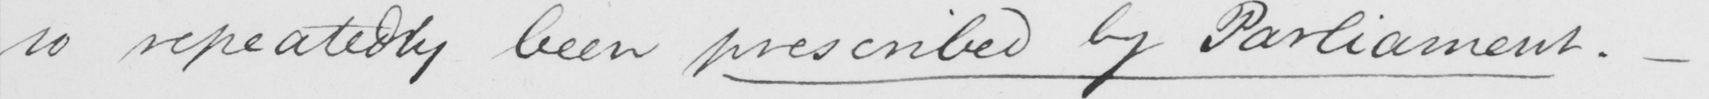What is written in this line of handwriting? so repeatedly been prescribed by Parliament .  _ 